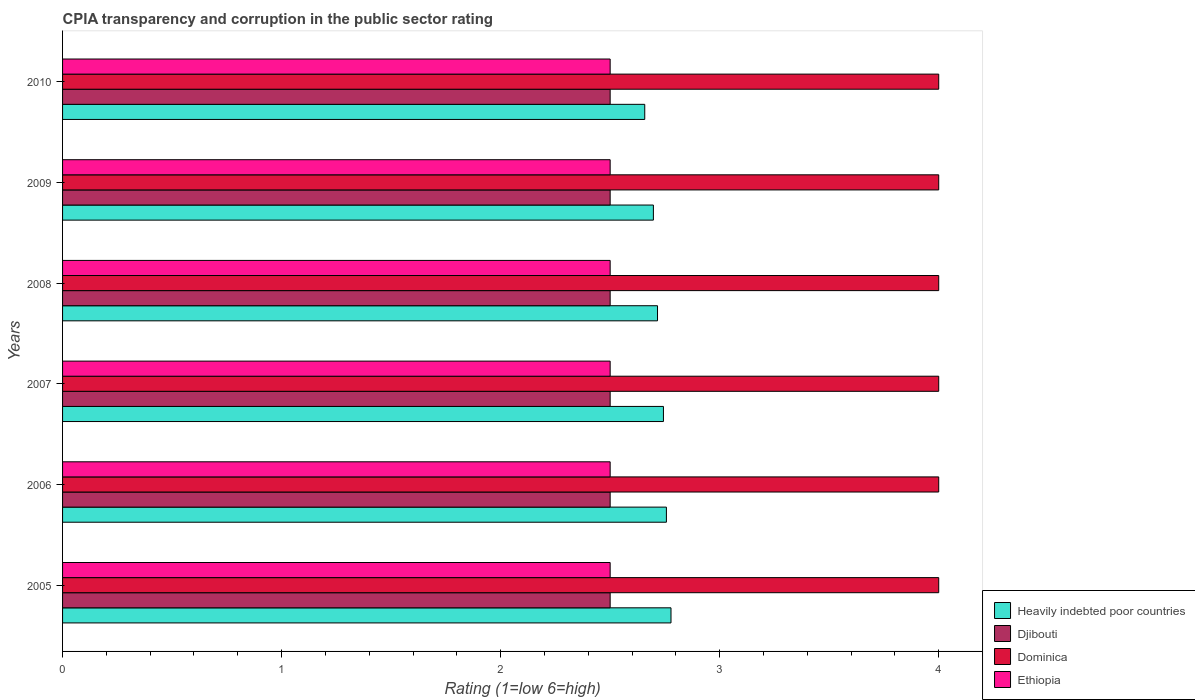How many different coloured bars are there?
Your answer should be very brief. 4. How many groups of bars are there?
Offer a terse response. 6. Are the number of bars per tick equal to the number of legend labels?
Your response must be concise. Yes. Are the number of bars on each tick of the Y-axis equal?
Offer a terse response. Yes. What is the label of the 2nd group of bars from the top?
Provide a succinct answer. 2009. Across all years, what is the maximum CPIA rating in Djibouti?
Make the answer very short. 2.5. Across all years, what is the minimum CPIA rating in Djibouti?
Keep it short and to the point. 2.5. In which year was the CPIA rating in Ethiopia maximum?
Give a very brief answer. 2005. In which year was the CPIA rating in Djibouti minimum?
Provide a succinct answer. 2005. What is the total CPIA rating in Dominica in the graph?
Ensure brevity in your answer.  24. What is the difference between the CPIA rating in Heavily indebted poor countries in 2009 and that in 2010?
Your answer should be very brief. 0.04. In the year 2010, what is the difference between the CPIA rating in Djibouti and CPIA rating in Ethiopia?
Your answer should be compact. 0. What is the ratio of the CPIA rating in Ethiopia in 2006 to that in 2007?
Your answer should be compact. 1. What is the difference between the highest and the lowest CPIA rating in Heavily indebted poor countries?
Give a very brief answer. 0.12. In how many years, is the CPIA rating in Ethiopia greater than the average CPIA rating in Ethiopia taken over all years?
Ensure brevity in your answer.  0. Is the sum of the CPIA rating in Heavily indebted poor countries in 2005 and 2006 greater than the maximum CPIA rating in Djibouti across all years?
Provide a short and direct response. Yes. What does the 3rd bar from the top in 2006 represents?
Your answer should be compact. Djibouti. What does the 2nd bar from the bottom in 2009 represents?
Your answer should be compact. Djibouti. Is it the case that in every year, the sum of the CPIA rating in Dominica and CPIA rating in Ethiopia is greater than the CPIA rating in Djibouti?
Provide a succinct answer. Yes. How many bars are there?
Ensure brevity in your answer.  24. Are all the bars in the graph horizontal?
Your response must be concise. Yes. How many years are there in the graph?
Provide a succinct answer. 6. Are the values on the major ticks of X-axis written in scientific E-notation?
Give a very brief answer. No. Does the graph contain any zero values?
Your response must be concise. No. Does the graph contain grids?
Give a very brief answer. No. What is the title of the graph?
Offer a terse response. CPIA transparency and corruption in the public sector rating. What is the label or title of the X-axis?
Make the answer very short. Rating (1=low 6=high). What is the label or title of the Y-axis?
Your answer should be compact. Years. What is the Rating (1=low 6=high) of Heavily indebted poor countries in 2005?
Keep it short and to the point. 2.78. What is the Rating (1=low 6=high) of Djibouti in 2005?
Offer a terse response. 2.5. What is the Rating (1=low 6=high) of Dominica in 2005?
Ensure brevity in your answer.  4. What is the Rating (1=low 6=high) of Heavily indebted poor countries in 2006?
Keep it short and to the point. 2.76. What is the Rating (1=low 6=high) of Djibouti in 2006?
Offer a very short reply. 2.5. What is the Rating (1=low 6=high) of Dominica in 2006?
Ensure brevity in your answer.  4. What is the Rating (1=low 6=high) of Heavily indebted poor countries in 2007?
Your answer should be very brief. 2.74. What is the Rating (1=low 6=high) of Djibouti in 2007?
Your response must be concise. 2.5. What is the Rating (1=low 6=high) in Ethiopia in 2007?
Give a very brief answer. 2.5. What is the Rating (1=low 6=high) in Heavily indebted poor countries in 2008?
Provide a short and direct response. 2.72. What is the Rating (1=low 6=high) of Ethiopia in 2008?
Offer a terse response. 2.5. What is the Rating (1=low 6=high) in Heavily indebted poor countries in 2009?
Provide a succinct answer. 2.7. What is the Rating (1=low 6=high) of Djibouti in 2009?
Provide a succinct answer. 2.5. What is the Rating (1=low 6=high) in Heavily indebted poor countries in 2010?
Give a very brief answer. 2.66. What is the Rating (1=low 6=high) of Dominica in 2010?
Make the answer very short. 4. What is the Rating (1=low 6=high) of Ethiopia in 2010?
Offer a very short reply. 2.5. Across all years, what is the maximum Rating (1=low 6=high) in Heavily indebted poor countries?
Provide a succinct answer. 2.78. Across all years, what is the maximum Rating (1=low 6=high) of Dominica?
Your answer should be very brief. 4. Across all years, what is the minimum Rating (1=low 6=high) of Heavily indebted poor countries?
Your answer should be very brief. 2.66. What is the total Rating (1=low 6=high) in Heavily indebted poor countries in the graph?
Your answer should be very brief. 16.35. What is the total Rating (1=low 6=high) in Ethiopia in the graph?
Offer a terse response. 15. What is the difference between the Rating (1=low 6=high) of Heavily indebted poor countries in 2005 and that in 2006?
Offer a terse response. 0.02. What is the difference between the Rating (1=low 6=high) in Djibouti in 2005 and that in 2006?
Give a very brief answer. 0. What is the difference between the Rating (1=low 6=high) in Dominica in 2005 and that in 2006?
Your answer should be compact. 0. What is the difference between the Rating (1=low 6=high) of Ethiopia in 2005 and that in 2006?
Your response must be concise. 0. What is the difference between the Rating (1=low 6=high) in Heavily indebted poor countries in 2005 and that in 2007?
Keep it short and to the point. 0.03. What is the difference between the Rating (1=low 6=high) in Ethiopia in 2005 and that in 2007?
Provide a short and direct response. 0. What is the difference between the Rating (1=low 6=high) in Heavily indebted poor countries in 2005 and that in 2008?
Offer a very short reply. 0.06. What is the difference between the Rating (1=low 6=high) in Djibouti in 2005 and that in 2008?
Your answer should be very brief. 0. What is the difference between the Rating (1=low 6=high) of Dominica in 2005 and that in 2008?
Make the answer very short. 0. What is the difference between the Rating (1=low 6=high) in Heavily indebted poor countries in 2005 and that in 2009?
Offer a terse response. 0.08. What is the difference between the Rating (1=low 6=high) of Dominica in 2005 and that in 2009?
Provide a short and direct response. 0. What is the difference between the Rating (1=low 6=high) of Ethiopia in 2005 and that in 2009?
Offer a very short reply. 0. What is the difference between the Rating (1=low 6=high) of Heavily indebted poor countries in 2005 and that in 2010?
Your answer should be compact. 0.12. What is the difference between the Rating (1=low 6=high) of Djibouti in 2005 and that in 2010?
Your response must be concise. 0. What is the difference between the Rating (1=low 6=high) in Dominica in 2005 and that in 2010?
Give a very brief answer. 0. What is the difference between the Rating (1=low 6=high) in Heavily indebted poor countries in 2006 and that in 2007?
Offer a very short reply. 0.01. What is the difference between the Rating (1=low 6=high) of Djibouti in 2006 and that in 2007?
Provide a short and direct response. 0. What is the difference between the Rating (1=low 6=high) of Dominica in 2006 and that in 2007?
Your answer should be compact. 0. What is the difference between the Rating (1=low 6=high) of Ethiopia in 2006 and that in 2007?
Offer a terse response. 0. What is the difference between the Rating (1=low 6=high) in Heavily indebted poor countries in 2006 and that in 2008?
Your answer should be compact. 0.04. What is the difference between the Rating (1=low 6=high) of Dominica in 2006 and that in 2008?
Ensure brevity in your answer.  0. What is the difference between the Rating (1=low 6=high) of Ethiopia in 2006 and that in 2008?
Ensure brevity in your answer.  0. What is the difference between the Rating (1=low 6=high) in Heavily indebted poor countries in 2006 and that in 2009?
Your response must be concise. 0.06. What is the difference between the Rating (1=low 6=high) in Djibouti in 2006 and that in 2009?
Offer a terse response. 0. What is the difference between the Rating (1=low 6=high) of Dominica in 2006 and that in 2009?
Give a very brief answer. 0. What is the difference between the Rating (1=low 6=high) in Heavily indebted poor countries in 2006 and that in 2010?
Make the answer very short. 0.1. What is the difference between the Rating (1=low 6=high) of Djibouti in 2006 and that in 2010?
Ensure brevity in your answer.  0. What is the difference between the Rating (1=low 6=high) in Dominica in 2006 and that in 2010?
Provide a succinct answer. 0. What is the difference between the Rating (1=low 6=high) in Heavily indebted poor countries in 2007 and that in 2008?
Provide a succinct answer. 0.03. What is the difference between the Rating (1=low 6=high) of Djibouti in 2007 and that in 2008?
Ensure brevity in your answer.  0. What is the difference between the Rating (1=low 6=high) of Ethiopia in 2007 and that in 2008?
Provide a short and direct response. 0. What is the difference between the Rating (1=low 6=high) of Heavily indebted poor countries in 2007 and that in 2009?
Provide a short and direct response. 0.05. What is the difference between the Rating (1=low 6=high) of Djibouti in 2007 and that in 2009?
Your answer should be compact. 0. What is the difference between the Rating (1=low 6=high) in Ethiopia in 2007 and that in 2009?
Your answer should be compact. 0. What is the difference between the Rating (1=low 6=high) in Heavily indebted poor countries in 2007 and that in 2010?
Your answer should be compact. 0.09. What is the difference between the Rating (1=low 6=high) in Djibouti in 2007 and that in 2010?
Make the answer very short. 0. What is the difference between the Rating (1=low 6=high) in Heavily indebted poor countries in 2008 and that in 2009?
Make the answer very short. 0.02. What is the difference between the Rating (1=low 6=high) of Djibouti in 2008 and that in 2009?
Ensure brevity in your answer.  0. What is the difference between the Rating (1=low 6=high) of Heavily indebted poor countries in 2008 and that in 2010?
Offer a terse response. 0.06. What is the difference between the Rating (1=low 6=high) of Ethiopia in 2008 and that in 2010?
Offer a very short reply. 0. What is the difference between the Rating (1=low 6=high) of Heavily indebted poor countries in 2009 and that in 2010?
Keep it short and to the point. 0.04. What is the difference between the Rating (1=low 6=high) of Heavily indebted poor countries in 2005 and the Rating (1=low 6=high) of Djibouti in 2006?
Make the answer very short. 0.28. What is the difference between the Rating (1=low 6=high) of Heavily indebted poor countries in 2005 and the Rating (1=low 6=high) of Dominica in 2006?
Give a very brief answer. -1.22. What is the difference between the Rating (1=low 6=high) in Heavily indebted poor countries in 2005 and the Rating (1=low 6=high) in Ethiopia in 2006?
Provide a succinct answer. 0.28. What is the difference between the Rating (1=low 6=high) in Djibouti in 2005 and the Rating (1=low 6=high) in Ethiopia in 2006?
Make the answer very short. 0. What is the difference between the Rating (1=low 6=high) in Dominica in 2005 and the Rating (1=low 6=high) in Ethiopia in 2006?
Give a very brief answer. 1.5. What is the difference between the Rating (1=low 6=high) in Heavily indebted poor countries in 2005 and the Rating (1=low 6=high) in Djibouti in 2007?
Your answer should be very brief. 0.28. What is the difference between the Rating (1=low 6=high) of Heavily indebted poor countries in 2005 and the Rating (1=low 6=high) of Dominica in 2007?
Offer a terse response. -1.22. What is the difference between the Rating (1=low 6=high) of Heavily indebted poor countries in 2005 and the Rating (1=low 6=high) of Ethiopia in 2007?
Give a very brief answer. 0.28. What is the difference between the Rating (1=low 6=high) in Djibouti in 2005 and the Rating (1=low 6=high) in Dominica in 2007?
Offer a very short reply. -1.5. What is the difference between the Rating (1=low 6=high) in Djibouti in 2005 and the Rating (1=low 6=high) in Ethiopia in 2007?
Make the answer very short. 0. What is the difference between the Rating (1=low 6=high) of Heavily indebted poor countries in 2005 and the Rating (1=low 6=high) of Djibouti in 2008?
Your response must be concise. 0.28. What is the difference between the Rating (1=low 6=high) in Heavily indebted poor countries in 2005 and the Rating (1=low 6=high) in Dominica in 2008?
Your answer should be very brief. -1.22. What is the difference between the Rating (1=low 6=high) in Heavily indebted poor countries in 2005 and the Rating (1=low 6=high) in Ethiopia in 2008?
Offer a very short reply. 0.28. What is the difference between the Rating (1=low 6=high) in Djibouti in 2005 and the Rating (1=low 6=high) in Dominica in 2008?
Your answer should be compact. -1.5. What is the difference between the Rating (1=low 6=high) in Dominica in 2005 and the Rating (1=low 6=high) in Ethiopia in 2008?
Provide a short and direct response. 1.5. What is the difference between the Rating (1=low 6=high) in Heavily indebted poor countries in 2005 and the Rating (1=low 6=high) in Djibouti in 2009?
Provide a succinct answer. 0.28. What is the difference between the Rating (1=low 6=high) in Heavily indebted poor countries in 2005 and the Rating (1=low 6=high) in Dominica in 2009?
Your answer should be compact. -1.22. What is the difference between the Rating (1=low 6=high) in Heavily indebted poor countries in 2005 and the Rating (1=low 6=high) in Ethiopia in 2009?
Ensure brevity in your answer.  0.28. What is the difference between the Rating (1=low 6=high) in Dominica in 2005 and the Rating (1=low 6=high) in Ethiopia in 2009?
Provide a short and direct response. 1.5. What is the difference between the Rating (1=low 6=high) in Heavily indebted poor countries in 2005 and the Rating (1=low 6=high) in Djibouti in 2010?
Provide a short and direct response. 0.28. What is the difference between the Rating (1=low 6=high) of Heavily indebted poor countries in 2005 and the Rating (1=low 6=high) of Dominica in 2010?
Keep it short and to the point. -1.22. What is the difference between the Rating (1=low 6=high) in Heavily indebted poor countries in 2005 and the Rating (1=low 6=high) in Ethiopia in 2010?
Offer a terse response. 0.28. What is the difference between the Rating (1=low 6=high) of Djibouti in 2005 and the Rating (1=low 6=high) of Dominica in 2010?
Provide a short and direct response. -1.5. What is the difference between the Rating (1=low 6=high) of Djibouti in 2005 and the Rating (1=low 6=high) of Ethiopia in 2010?
Provide a succinct answer. 0. What is the difference between the Rating (1=low 6=high) of Dominica in 2005 and the Rating (1=low 6=high) of Ethiopia in 2010?
Offer a terse response. 1.5. What is the difference between the Rating (1=low 6=high) in Heavily indebted poor countries in 2006 and the Rating (1=low 6=high) in Djibouti in 2007?
Ensure brevity in your answer.  0.26. What is the difference between the Rating (1=low 6=high) in Heavily indebted poor countries in 2006 and the Rating (1=low 6=high) in Dominica in 2007?
Offer a terse response. -1.24. What is the difference between the Rating (1=low 6=high) of Heavily indebted poor countries in 2006 and the Rating (1=low 6=high) of Ethiopia in 2007?
Provide a succinct answer. 0.26. What is the difference between the Rating (1=low 6=high) of Djibouti in 2006 and the Rating (1=low 6=high) of Dominica in 2007?
Your answer should be very brief. -1.5. What is the difference between the Rating (1=low 6=high) in Djibouti in 2006 and the Rating (1=low 6=high) in Ethiopia in 2007?
Provide a short and direct response. 0. What is the difference between the Rating (1=low 6=high) in Heavily indebted poor countries in 2006 and the Rating (1=low 6=high) in Djibouti in 2008?
Your response must be concise. 0.26. What is the difference between the Rating (1=low 6=high) in Heavily indebted poor countries in 2006 and the Rating (1=low 6=high) in Dominica in 2008?
Provide a short and direct response. -1.24. What is the difference between the Rating (1=low 6=high) in Heavily indebted poor countries in 2006 and the Rating (1=low 6=high) in Ethiopia in 2008?
Your answer should be compact. 0.26. What is the difference between the Rating (1=low 6=high) of Djibouti in 2006 and the Rating (1=low 6=high) of Ethiopia in 2008?
Make the answer very short. 0. What is the difference between the Rating (1=low 6=high) in Dominica in 2006 and the Rating (1=low 6=high) in Ethiopia in 2008?
Offer a very short reply. 1.5. What is the difference between the Rating (1=low 6=high) in Heavily indebted poor countries in 2006 and the Rating (1=low 6=high) in Djibouti in 2009?
Offer a terse response. 0.26. What is the difference between the Rating (1=low 6=high) of Heavily indebted poor countries in 2006 and the Rating (1=low 6=high) of Dominica in 2009?
Keep it short and to the point. -1.24. What is the difference between the Rating (1=low 6=high) of Heavily indebted poor countries in 2006 and the Rating (1=low 6=high) of Ethiopia in 2009?
Ensure brevity in your answer.  0.26. What is the difference between the Rating (1=low 6=high) in Djibouti in 2006 and the Rating (1=low 6=high) in Dominica in 2009?
Provide a short and direct response. -1.5. What is the difference between the Rating (1=low 6=high) in Djibouti in 2006 and the Rating (1=low 6=high) in Ethiopia in 2009?
Your answer should be compact. 0. What is the difference between the Rating (1=low 6=high) of Heavily indebted poor countries in 2006 and the Rating (1=low 6=high) of Djibouti in 2010?
Your response must be concise. 0.26. What is the difference between the Rating (1=low 6=high) in Heavily indebted poor countries in 2006 and the Rating (1=low 6=high) in Dominica in 2010?
Your answer should be compact. -1.24. What is the difference between the Rating (1=low 6=high) in Heavily indebted poor countries in 2006 and the Rating (1=low 6=high) in Ethiopia in 2010?
Provide a short and direct response. 0.26. What is the difference between the Rating (1=low 6=high) of Djibouti in 2006 and the Rating (1=low 6=high) of Ethiopia in 2010?
Make the answer very short. 0. What is the difference between the Rating (1=low 6=high) in Heavily indebted poor countries in 2007 and the Rating (1=low 6=high) in Djibouti in 2008?
Offer a very short reply. 0.24. What is the difference between the Rating (1=low 6=high) in Heavily indebted poor countries in 2007 and the Rating (1=low 6=high) in Dominica in 2008?
Your answer should be very brief. -1.26. What is the difference between the Rating (1=low 6=high) of Heavily indebted poor countries in 2007 and the Rating (1=low 6=high) of Ethiopia in 2008?
Keep it short and to the point. 0.24. What is the difference between the Rating (1=low 6=high) of Dominica in 2007 and the Rating (1=low 6=high) of Ethiopia in 2008?
Offer a terse response. 1.5. What is the difference between the Rating (1=low 6=high) of Heavily indebted poor countries in 2007 and the Rating (1=low 6=high) of Djibouti in 2009?
Your answer should be very brief. 0.24. What is the difference between the Rating (1=low 6=high) in Heavily indebted poor countries in 2007 and the Rating (1=low 6=high) in Dominica in 2009?
Ensure brevity in your answer.  -1.26. What is the difference between the Rating (1=low 6=high) in Heavily indebted poor countries in 2007 and the Rating (1=low 6=high) in Ethiopia in 2009?
Make the answer very short. 0.24. What is the difference between the Rating (1=low 6=high) of Djibouti in 2007 and the Rating (1=low 6=high) of Dominica in 2009?
Your answer should be compact. -1.5. What is the difference between the Rating (1=low 6=high) in Dominica in 2007 and the Rating (1=low 6=high) in Ethiopia in 2009?
Make the answer very short. 1.5. What is the difference between the Rating (1=low 6=high) of Heavily indebted poor countries in 2007 and the Rating (1=low 6=high) of Djibouti in 2010?
Ensure brevity in your answer.  0.24. What is the difference between the Rating (1=low 6=high) of Heavily indebted poor countries in 2007 and the Rating (1=low 6=high) of Dominica in 2010?
Your response must be concise. -1.26. What is the difference between the Rating (1=low 6=high) in Heavily indebted poor countries in 2007 and the Rating (1=low 6=high) in Ethiopia in 2010?
Your answer should be very brief. 0.24. What is the difference between the Rating (1=low 6=high) in Djibouti in 2007 and the Rating (1=low 6=high) in Dominica in 2010?
Your answer should be very brief. -1.5. What is the difference between the Rating (1=low 6=high) in Djibouti in 2007 and the Rating (1=low 6=high) in Ethiopia in 2010?
Keep it short and to the point. 0. What is the difference between the Rating (1=low 6=high) in Heavily indebted poor countries in 2008 and the Rating (1=low 6=high) in Djibouti in 2009?
Make the answer very short. 0.22. What is the difference between the Rating (1=low 6=high) of Heavily indebted poor countries in 2008 and the Rating (1=low 6=high) of Dominica in 2009?
Offer a terse response. -1.28. What is the difference between the Rating (1=low 6=high) of Heavily indebted poor countries in 2008 and the Rating (1=low 6=high) of Ethiopia in 2009?
Your answer should be very brief. 0.22. What is the difference between the Rating (1=low 6=high) in Djibouti in 2008 and the Rating (1=low 6=high) in Dominica in 2009?
Your answer should be very brief. -1.5. What is the difference between the Rating (1=low 6=high) in Dominica in 2008 and the Rating (1=low 6=high) in Ethiopia in 2009?
Your answer should be very brief. 1.5. What is the difference between the Rating (1=low 6=high) of Heavily indebted poor countries in 2008 and the Rating (1=low 6=high) of Djibouti in 2010?
Provide a short and direct response. 0.22. What is the difference between the Rating (1=low 6=high) in Heavily indebted poor countries in 2008 and the Rating (1=low 6=high) in Dominica in 2010?
Your answer should be compact. -1.28. What is the difference between the Rating (1=low 6=high) in Heavily indebted poor countries in 2008 and the Rating (1=low 6=high) in Ethiopia in 2010?
Give a very brief answer. 0.22. What is the difference between the Rating (1=low 6=high) of Djibouti in 2008 and the Rating (1=low 6=high) of Dominica in 2010?
Your answer should be compact. -1.5. What is the difference between the Rating (1=low 6=high) in Heavily indebted poor countries in 2009 and the Rating (1=low 6=high) in Djibouti in 2010?
Offer a very short reply. 0.2. What is the difference between the Rating (1=low 6=high) in Heavily indebted poor countries in 2009 and the Rating (1=low 6=high) in Dominica in 2010?
Make the answer very short. -1.3. What is the difference between the Rating (1=low 6=high) of Heavily indebted poor countries in 2009 and the Rating (1=low 6=high) of Ethiopia in 2010?
Give a very brief answer. 0.2. What is the difference between the Rating (1=low 6=high) in Djibouti in 2009 and the Rating (1=low 6=high) in Ethiopia in 2010?
Ensure brevity in your answer.  0. What is the difference between the Rating (1=low 6=high) in Dominica in 2009 and the Rating (1=low 6=high) in Ethiopia in 2010?
Your response must be concise. 1.5. What is the average Rating (1=low 6=high) of Heavily indebted poor countries per year?
Provide a short and direct response. 2.72. What is the average Rating (1=low 6=high) of Dominica per year?
Offer a very short reply. 4. What is the average Rating (1=low 6=high) of Ethiopia per year?
Provide a succinct answer. 2.5. In the year 2005, what is the difference between the Rating (1=low 6=high) in Heavily indebted poor countries and Rating (1=low 6=high) in Djibouti?
Offer a very short reply. 0.28. In the year 2005, what is the difference between the Rating (1=low 6=high) of Heavily indebted poor countries and Rating (1=low 6=high) of Dominica?
Your answer should be compact. -1.22. In the year 2005, what is the difference between the Rating (1=low 6=high) in Heavily indebted poor countries and Rating (1=low 6=high) in Ethiopia?
Your response must be concise. 0.28. In the year 2006, what is the difference between the Rating (1=low 6=high) of Heavily indebted poor countries and Rating (1=low 6=high) of Djibouti?
Your response must be concise. 0.26. In the year 2006, what is the difference between the Rating (1=low 6=high) of Heavily indebted poor countries and Rating (1=low 6=high) of Dominica?
Ensure brevity in your answer.  -1.24. In the year 2006, what is the difference between the Rating (1=low 6=high) in Heavily indebted poor countries and Rating (1=low 6=high) in Ethiopia?
Provide a short and direct response. 0.26. In the year 2007, what is the difference between the Rating (1=low 6=high) of Heavily indebted poor countries and Rating (1=low 6=high) of Djibouti?
Provide a short and direct response. 0.24. In the year 2007, what is the difference between the Rating (1=low 6=high) in Heavily indebted poor countries and Rating (1=low 6=high) in Dominica?
Your answer should be compact. -1.26. In the year 2007, what is the difference between the Rating (1=low 6=high) in Heavily indebted poor countries and Rating (1=low 6=high) in Ethiopia?
Make the answer very short. 0.24. In the year 2007, what is the difference between the Rating (1=low 6=high) of Djibouti and Rating (1=low 6=high) of Dominica?
Give a very brief answer. -1.5. In the year 2007, what is the difference between the Rating (1=low 6=high) of Dominica and Rating (1=low 6=high) of Ethiopia?
Give a very brief answer. 1.5. In the year 2008, what is the difference between the Rating (1=low 6=high) in Heavily indebted poor countries and Rating (1=low 6=high) in Djibouti?
Make the answer very short. 0.22. In the year 2008, what is the difference between the Rating (1=low 6=high) of Heavily indebted poor countries and Rating (1=low 6=high) of Dominica?
Your response must be concise. -1.28. In the year 2008, what is the difference between the Rating (1=low 6=high) in Heavily indebted poor countries and Rating (1=low 6=high) in Ethiopia?
Make the answer very short. 0.22. In the year 2008, what is the difference between the Rating (1=low 6=high) in Djibouti and Rating (1=low 6=high) in Dominica?
Offer a terse response. -1.5. In the year 2008, what is the difference between the Rating (1=low 6=high) of Dominica and Rating (1=low 6=high) of Ethiopia?
Your response must be concise. 1.5. In the year 2009, what is the difference between the Rating (1=low 6=high) of Heavily indebted poor countries and Rating (1=low 6=high) of Djibouti?
Ensure brevity in your answer.  0.2. In the year 2009, what is the difference between the Rating (1=low 6=high) of Heavily indebted poor countries and Rating (1=low 6=high) of Dominica?
Provide a short and direct response. -1.3. In the year 2009, what is the difference between the Rating (1=low 6=high) in Heavily indebted poor countries and Rating (1=low 6=high) in Ethiopia?
Offer a very short reply. 0.2. In the year 2009, what is the difference between the Rating (1=low 6=high) in Djibouti and Rating (1=low 6=high) in Dominica?
Keep it short and to the point. -1.5. In the year 2009, what is the difference between the Rating (1=low 6=high) of Dominica and Rating (1=low 6=high) of Ethiopia?
Make the answer very short. 1.5. In the year 2010, what is the difference between the Rating (1=low 6=high) in Heavily indebted poor countries and Rating (1=low 6=high) in Djibouti?
Your answer should be very brief. 0.16. In the year 2010, what is the difference between the Rating (1=low 6=high) of Heavily indebted poor countries and Rating (1=low 6=high) of Dominica?
Your answer should be very brief. -1.34. In the year 2010, what is the difference between the Rating (1=low 6=high) in Heavily indebted poor countries and Rating (1=low 6=high) in Ethiopia?
Offer a very short reply. 0.16. In the year 2010, what is the difference between the Rating (1=low 6=high) in Djibouti and Rating (1=low 6=high) in Ethiopia?
Your answer should be compact. 0. What is the ratio of the Rating (1=low 6=high) of Heavily indebted poor countries in 2005 to that in 2006?
Your answer should be compact. 1.01. What is the ratio of the Rating (1=low 6=high) in Heavily indebted poor countries in 2005 to that in 2007?
Provide a short and direct response. 1.01. What is the ratio of the Rating (1=low 6=high) in Djibouti in 2005 to that in 2007?
Make the answer very short. 1. What is the ratio of the Rating (1=low 6=high) in Heavily indebted poor countries in 2005 to that in 2008?
Make the answer very short. 1.02. What is the ratio of the Rating (1=low 6=high) in Djibouti in 2005 to that in 2008?
Your response must be concise. 1. What is the ratio of the Rating (1=low 6=high) of Heavily indebted poor countries in 2005 to that in 2009?
Provide a succinct answer. 1.03. What is the ratio of the Rating (1=low 6=high) in Heavily indebted poor countries in 2005 to that in 2010?
Your answer should be compact. 1.05. What is the ratio of the Rating (1=low 6=high) of Djibouti in 2005 to that in 2010?
Offer a very short reply. 1. What is the ratio of the Rating (1=low 6=high) in Dominica in 2005 to that in 2010?
Provide a succinct answer. 1. What is the ratio of the Rating (1=low 6=high) of Ethiopia in 2005 to that in 2010?
Give a very brief answer. 1. What is the ratio of the Rating (1=low 6=high) in Heavily indebted poor countries in 2006 to that in 2007?
Your response must be concise. 1. What is the ratio of the Rating (1=low 6=high) of Djibouti in 2006 to that in 2007?
Your response must be concise. 1. What is the ratio of the Rating (1=low 6=high) in Heavily indebted poor countries in 2006 to that in 2008?
Make the answer very short. 1.01. What is the ratio of the Rating (1=low 6=high) of Dominica in 2006 to that in 2008?
Provide a succinct answer. 1. What is the ratio of the Rating (1=low 6=high) of Djibouti in 2006 to that in 2009?
Your answer should be compact. 1. What is the ratio of the Rating (1=low 6=high) in Dominica in 2006 to that in 2009?
Your answer should be very brief. 1. What is the ratio of the Rating (1=low 6=high) of Heavily indebted poor countries in 2006 to that in 2010?
Your response must be concise. 1.04. What is the ratio of the Rating (1=low 6=high) in Djibouti in 2006 to that in 2010?
Provide a succinct answer. 1. What is the ratio of the Rating (1=low 6=high) of Ethiopia in 2007 to that in 2008?
Your answer should be very brief. 1. What is the ratio of the Rating (1=low 6=high) of Djibouti in 2007 to that in 2009?
Give a very brief answer. 1. What is the ratio of the Rating (1=low 6=high) in Dominica in 2007 to that in 2009?
Offer a very short reply. 1. What is the ratio of the Rating (1=low 6=high) of Heavily indebted poor countries in 2007 to that in 2010?
Offer a very short reply. 1.03. What is the ratio of the Rating (1=low 6=high) of Dominica in 2007 to that in 2010?
Your response must be concise. 1. What is the ratio of the Rating (1=low 6=high) of Ethiopia in 2007 to that in 2010?
Your answer should be very brief. 1. What is the ratio of the Rating (1=low 6=high) in Dominica in 2008 to that in 2009?
Offer a terse response. 1. What is the ratio of the Rating (1=low 6=high) of Ethiopia in 2008 to that in 2009?
Your answer should be compact. 1. What is the ratio of the Rating (1=low 6=high) in Heavily indebted poor countries in 2008 to that in 2010?
Offer a very short reply. 1.02. What is the ratio of the Rating (1=low 6=high) of Djibouti in 2008 to that in 2010?
Keep it short and to the point. 1. What is the ratio of the Rating (1=low 6=high) of Dominica in 2008 to that in 2010?
Keep it short and to the point. 1. What is the ratio of the Rating (1=low 6=high) of Ethiopia in 2008 to that in 2010?
Your answer should be compact. 1. What is the ratio of the Rating (1=low 6=high) in Heavily indebted poor countries in 2009 to that in 2010?
Your answer should be very brief. 1.01. What is the ratio of the Rating (1=low 6=high) of Djibouti in 2009 to that in 2010?
Offer a very short reply. 1. What is the ratio of the Rating (1=low 6=high) of Dominica in 2009 to that in 2010?
Offer a very short reply. 1. What is the difference between the highest and the second highest Rating (1=low 6=high) in Heavily indebted poor countries?
Keep it short and to the point. 0.02. What is the difference between the highest and the second highest Rating (1=low 6=high) of Ethiopia?
Make the answer very short. 0. What is the difference between the highest and the lowest Rating (1=low 6=high) of Heavily indebted poor countries?
Ensure brevity in your answer.  0.12. What is the difference between the highest and the lowest Rating (1=low 6=high) of Dominica?
Give a very brief answer. 0. What is the difference between the highest and the lowest Rating (1=low 6=high) of Ethiopia?
Your answer should be very brief. 0. 